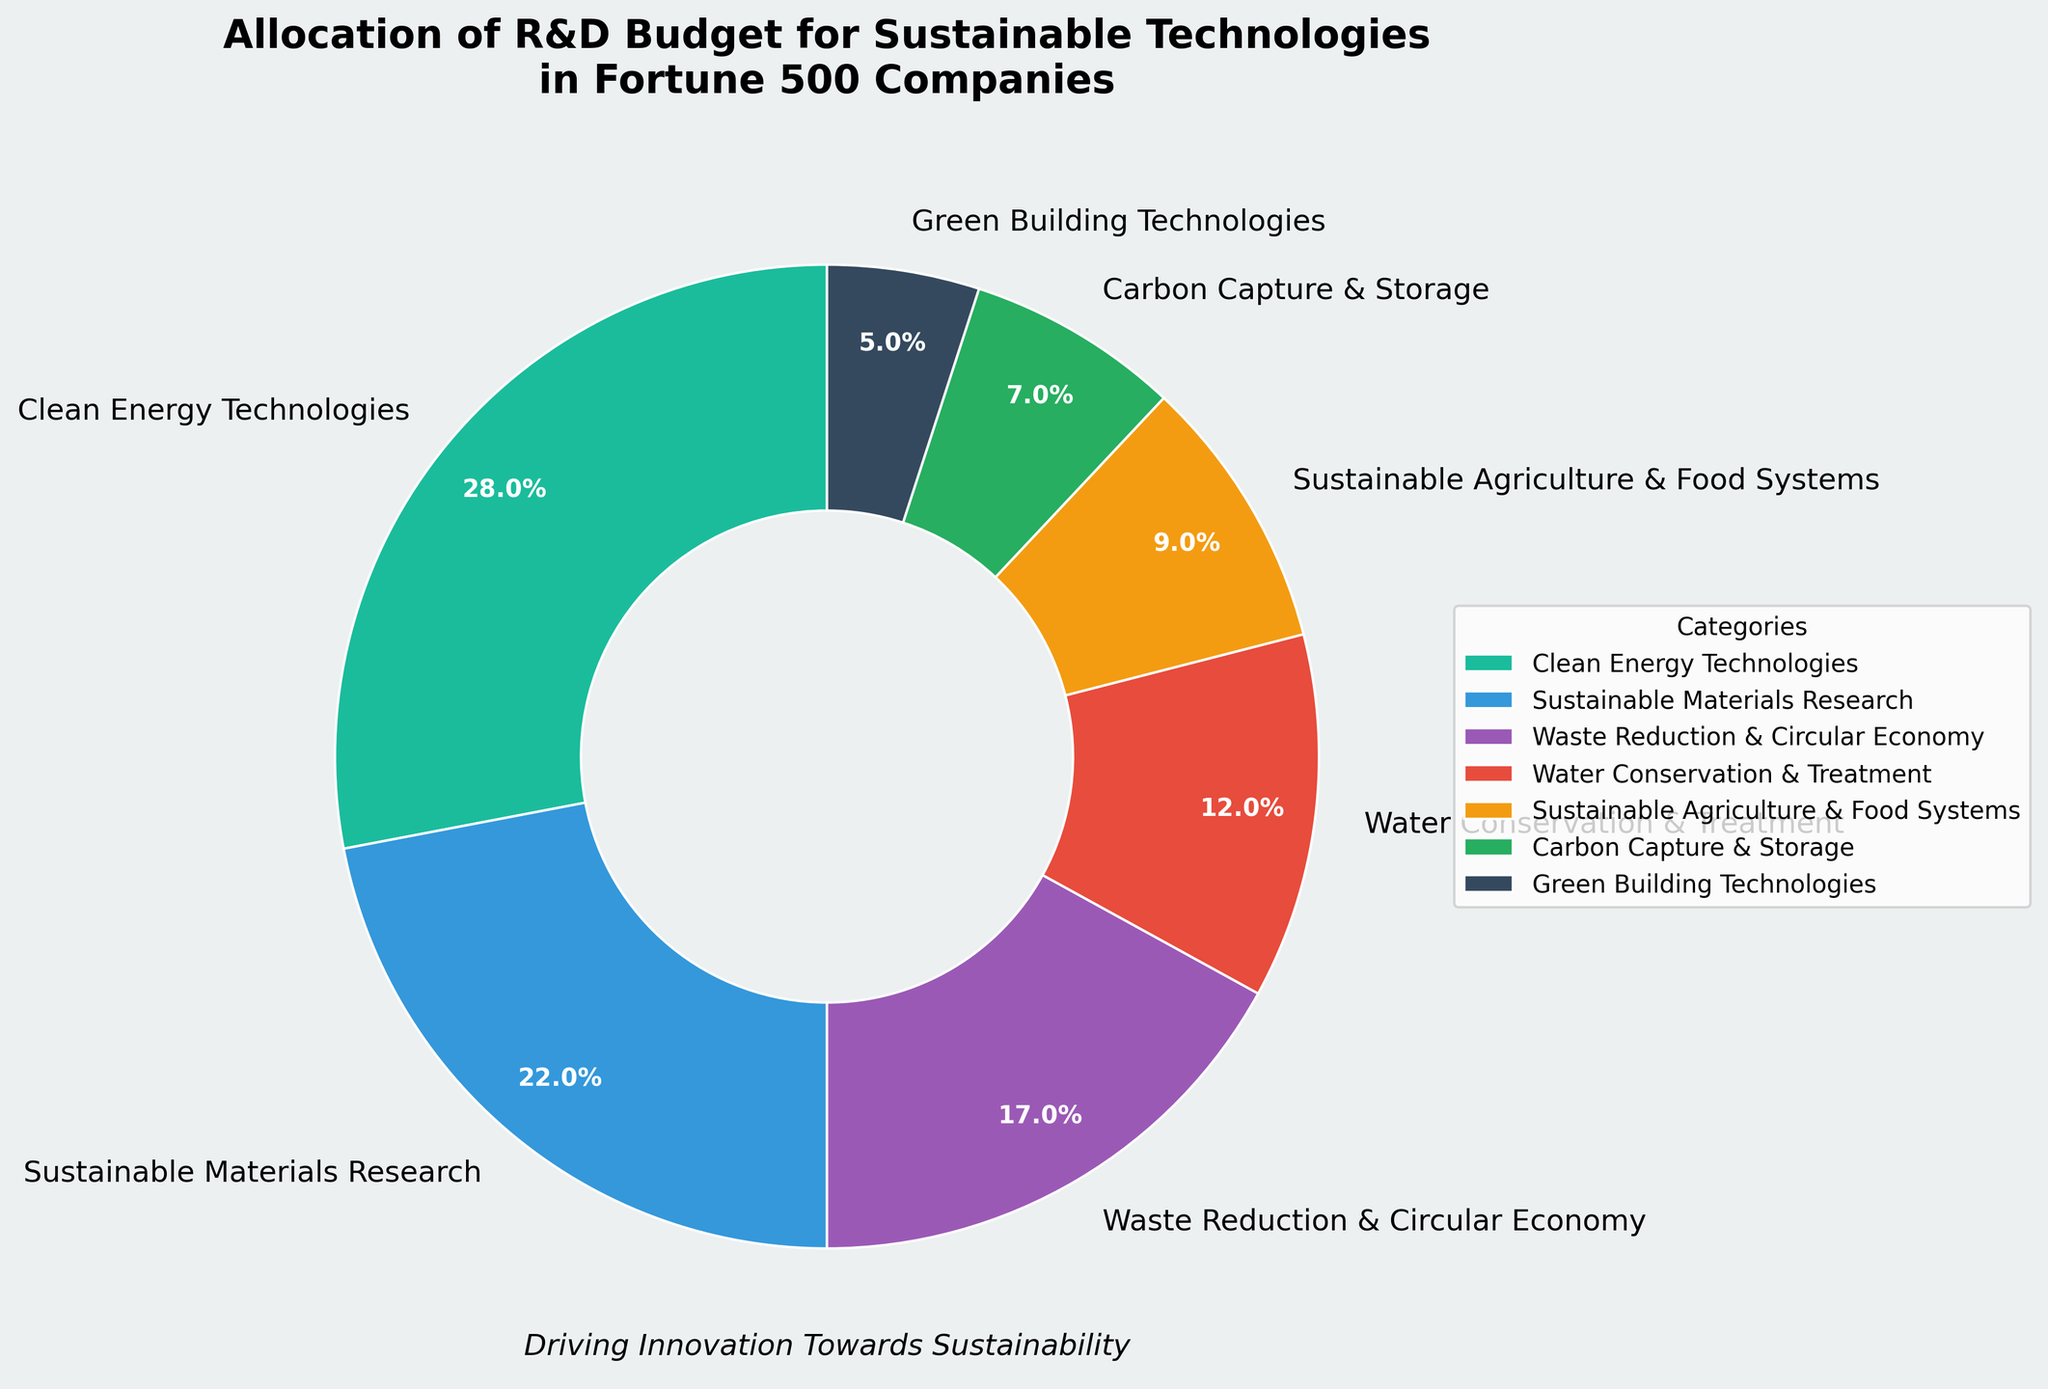What's the largest allocation of the R&D budget? The largest allocation segment is the one with the highest percentage on the pie chart. In this case, it is "Clean Energy Technologies" at 28%.
Answer: Clean Energy Technologies Which category has the smallest allocation of the R&D budget? The smallest allocation segment is the one with the lowest percentage on the pie chart. In this case, it is "Green Building Technologies" at 5%.
Answer: Green Building Technologies What percentage of the R&D budget is allocated to Clean Energy Technologies and Sustainable Materials Research combined? Add the percentages for "Clean Energy Technologies" (28%) and "Sustainable Materials Research" (22%). The sum is 28 + 22 = 50%.
Answer: 50% Compare the allocation for Waste Reduction & Circular Economy to Water Conservation & Treatment. Which one receives more funding? The percentage for "Waste Reduction & Circular Economy" is 17%, while for "Water Conservation & Treatment," it is 12%. Since 17% is greater than 12%, Waste Reduction & Circular Economy receives more funding.
Answer: Waste Reduction & Circular Economy What is the total percentage allocated to Sustainable Agriculture & Food Systems, Carbon Capture & Storage, and Green Building Technologies? Add the percentages for "Sustainable Agriculture & Food Systems" (9%), "Carbon Capture & Storage" (7%), and "Green Building Technologies" (5%). The sum is 9 + 7 + 5 = 21%.
Answer: 21% Is the allocation for Sustainable Materials Research higher than Carbon Capture & Storage and Green Building Technologies combined? The percentage for "Sustainable Materials Research" is 22%. The sum of "Carbon Capture & Storage" (7%) and "Green Building Technologies" (5%) is 7 + 5 = 12%. Since 22% is greater than 12%, the allocation for Sustainable Materials Research is higher.
Answer: Yes What percentage of the R&D budget is not allocated to Clean Energy Technologies? Subtract the percentage for "Clean Energy Technologies" (28%) from 100%. The result is 100 - 28 = 72%.
Answer: 72% How much more is allocated to Clean Energy Technologies compared to Carbon Capture & Storage? Subtract the percentage for "Carbon Capture & Storage" (7%) from "Clean Energy Technologies" (28%). The difference is 28 - 7 = 21%.
Answer: 21% Describe the color used for Clean Energy Technologies in the pie chart. Observe the segment corresponding to "Clean Energy Technologies" and identify the color. The color is a shade of green.
Answer: Green What is the combined allocation for the categories with the lowest and the highest funding? Identify the categories with the lowest and highest percentages: "Green Building Technologies" (5%) and "Clean Energy Technologies" (28%). Add these percentages together: 5 + 28 = 33%.
Answer: 33% 